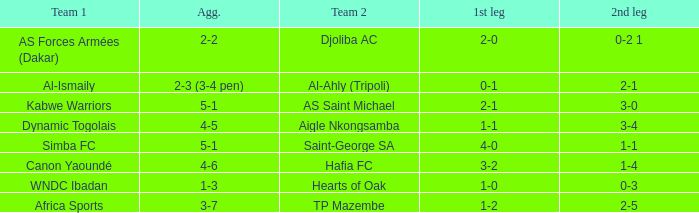When Kabwe Warriors (team 1) played, what was the result of the 1st leg? 2-1. 